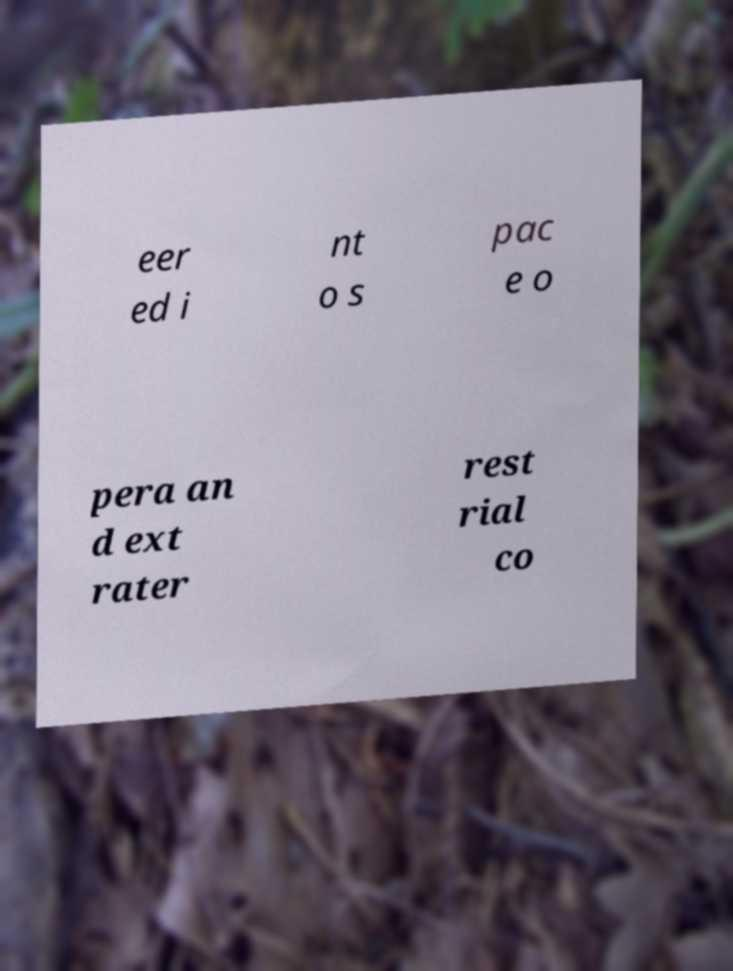Can you read and provide the text displayed in the image?This photo seems to have some interesting text. Can you extract and type it out for me? eer ed i nt o s pac e o pera an d ext rater rest rial co 